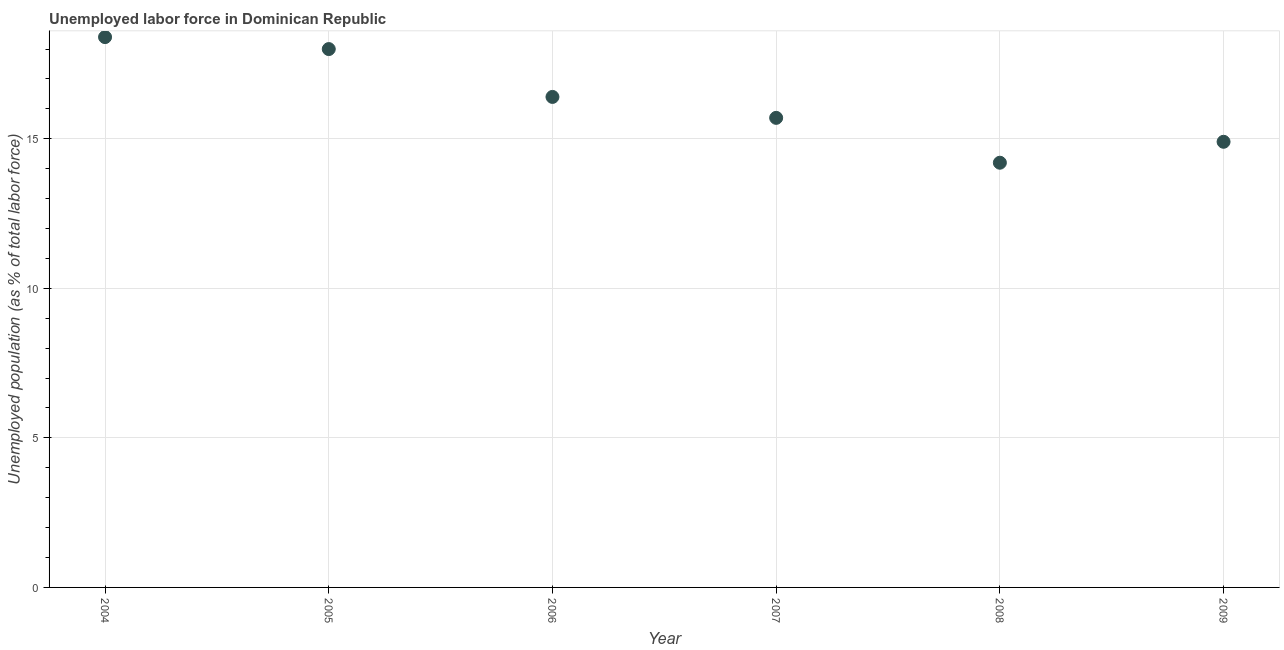What is the total unemployed population in 2009?
Give a very brief answer. 14.9. Across all years, what is the maximum total unemployed population?
Provide a short and direct response. 18.4. Across all years, what is the minimum total unemployed population?
Give a very brief answer. 14.2. In which year was the total unemployed population minimum?
Make the answer very short. 2008. What is the sum of the total unemployed population?
Your answer should be compact. 97.6. What is the difference between the total unemployed population in 2004 and 2005?
Offer a terse response. 0.4. What is the average total unemployed population per year?
Offer a very short reply. 16.27. What is the median total unemployed population?
Give a very brief answer. 16.05. In how many years, is the total unemployed population greater than 3 %?
Offer a very short reply. 6. What is the ratio of the total unemployed population in 2006 to that in 2009?
Your answer should be compact. 1.1. Is the total unemployed population in 2005 less than that in 2009?
Ensure brevity in your answer.  No. What is the difference between the highest and the second highest total unemployed population?
Make the answer very short. 0.4. What is the difference between the highest and the lowest total unemployed population?
Give a very brief answer. 4.2. In how many years, is the total unemployed population greater than the average total unemployed population taken over all years?
Give a very brief answer. 3. Does the total unemployed population monotonically increase over the years?
Your response must be concise. No. How many years are there in the graph?
Give a very brief answer. 6. Are the values on the major ticks of Y-axis written in scientific E-notation?
Ensure brevity in your answer.  No. Does the graph contain grids?
Your answer should be very brief. Yes. What is the title of the graph?
Offer a terse response. Unemployed labor force in Dominican Republic. What is the label or title of the X-axis?
Your answer should be compact. Year. What is the label or title of the Y-axis?
Your answer should be very brief. Unemployed population (as % of total labor force). What is the Unemployed population (as % of total labor force) in 2004?
Offer a terse response. 18.4. What is the Unemployed population (as % of total labor force) in 2005?
Offer a terse response. 18. What is the Unemployed population (as % of total labor force) in 2006?
Provide a short and direct response. 16.4. What is the Unemployed population (as % of total labor force) in 2007?
Offer a terse response. 15.7. What is the Unemployed population (as % of total labor force) in 2008?
Your answer should be compact. 14.2. What is the Unemployed population (as % of total labor force) in 2009?
Make the answer very short. 14.9. What is the difference between the Unemployed population (as % of total labor force) in 2004 and 2005?
Give a very brief answer. 0.4. What is the difference between the Unemployed population (as % of total labor force) in 2004 and 2006?
Offer a terse response. 2. What is the difference between the Unemployed population (as % of total labor force) in 2004 and 2007?
Ensure brevity in your answer.  2.7. What is the difference between the Unemployed population (as % of total labor force) in 2004 and 2009?
Your response must be concise. 3.5. What is the difference between the Unemployed population (as % of total labor force) in 2005 and 2006?
Offer a very short reply. 1.6. What is the difference between the Unemployed population (as % of total labor force) in 2005 and 2008?
Your answer should be compact. 3.8. What is the difference between the Unemployed population (as % of total labor force) in 2005 and 2009?
Provide a short and direct response. 3.1. What is the difference between the Unemployed population (as % of total labor force) in 2006 and 2009?
Provide a succinct answer. 1.5. What is the difference between the Unemployed population (as % of total labor force) in 2007 and 2008?
Give a very brief answer. 1.5. What is the difference between the Unemployed population (as % of total labor force) in 2007 and 2009?
Offer a terse response. 0.8. What is the difference between the Unemployed population (as % of total labor force) in 2008 and 2009?
Provide a short and direct response. -0.7. What is the ratio of the Unemployed population (as % of total labor force) in 2004 to that in 2005?
Ensure brevity in your answer.  1.02. What is the ratio of the Unemployed population (as % of total labor force) in 2004 to that in 2006?
Ensure brevity in your answer.  1.12. What is the ratio of the Unemployed population (as % of total labor force) in 2004 to that in 2007?
Give a very brief answer. 1.17. What is the ratio of the Unemployed population (as % of total labor force) in 2004 to that in 2008?
Provide a short and direct response. 1.3. What is the ratio of the Unemployed population (as % of total labor force) in 2004 to that in 2009?
Your response must be concise. 1.24. What is the ratio of the Unemployed population (as % of total labor force) in 2005 to that in 2006?
Your response must be concise. 1.1. What is the ratio of the Unemployed population (as % of total labor force) in 2005 to that in 2007?
Your answer should be very brief. 1.15. What is the ratio of the Unemployed population (as % of total labor force) in 2005 to that in 2008?
Offer a very short reply. 1.27. What is the ratio of the Unemployed population (as % of total labor force) in 2005 to that in 2009?
Offer a very short reply. 1.21. What is the ratio of the Unemployed population (as % of total labor force) in 2006 to that in 2007?
Offer a terse response. 1.04. What is the ratio of the Unemployed population (as % of total labor force) in 2006 to that in 2008?
Ensure brevity in your answer.  1.16. What is the ratio of the Unemployed population (as % of total labor force) in 2006 to that in 2009?
Provide a short and direct response. 1.1. What is the ratio of the Unemployed population (as % of total labor force) in 2007 to that in 2008?
Offer a very short reply. 1.11. What is the ratio of the Unemployed population (as % of total labor force) in 2007 to that in 2009?
Provide a short and direct response. 1.05. What is the ratio of the Unemployed population (as % of total labor force) in 2008 to that in 2009?
Provide a succinct answer. 0.95. 